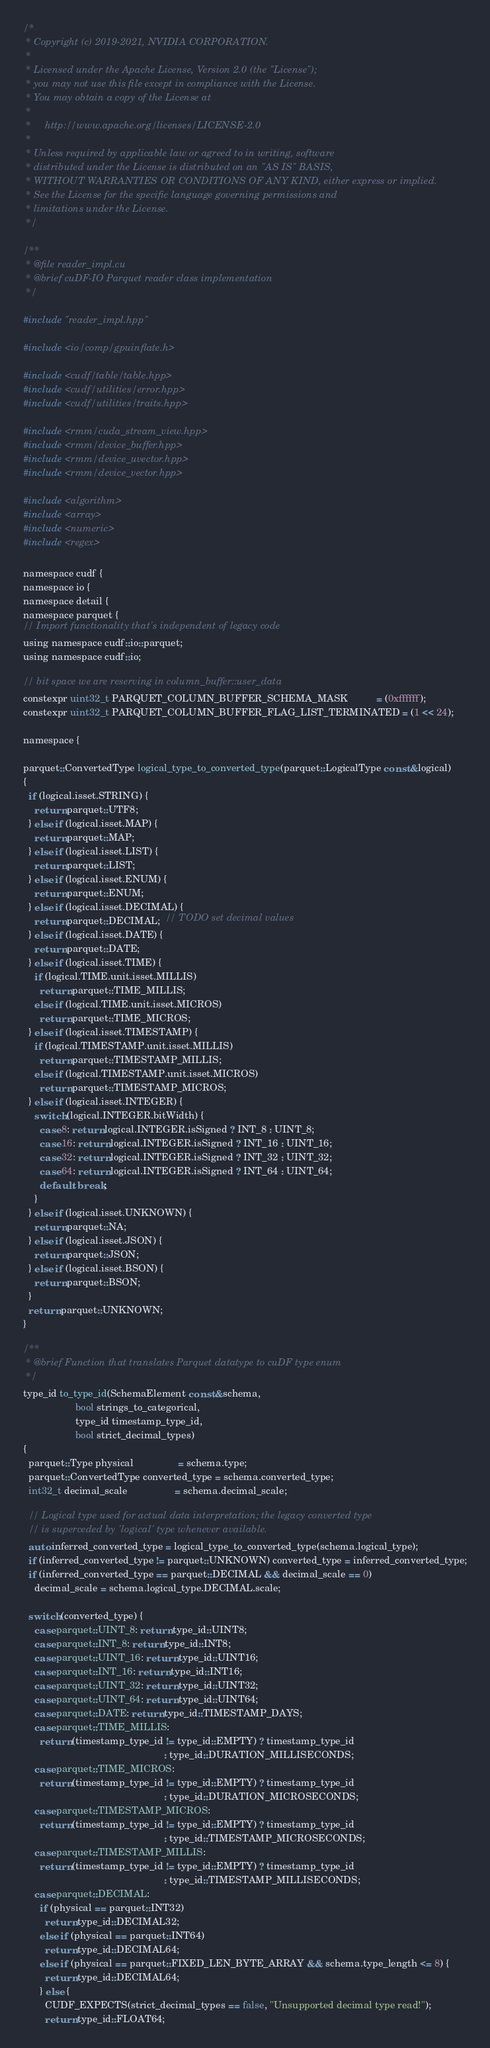<code> <loc_0><loc_0><loc_500><loc_500><_Cuda_>/*
 * Copyright (c) 2019-2021, NVIDIA CORPORATION.
 *
 * Licensed under the Apache License, Version 2.0 (the "License");
 * you may not use this file except in compliance with the License.
 * You may obtain a copy of the License at
 *
 *     http://www.apache.org/licenses/LICENSE-2.0
 *
 * Unless required by applicable law or agreed to in writing, software
 * distributed under the License is distributed on an "AS IS" BASIS,
 * WITHOUT WARRANTIES OR CONDITIONS OF ANY KIND, either express or implied.
 * See the License for the specific language governing permissions and
 * limitations under the License.
 */

/**
 * @file reader_impl.cu
 * @brief cuDF-IO Parquet reader class implementation
 */

#include "reader_impl.hpp"

#include <io/comp/gpuinflate.h>

#include <cudf/table/table.hpp>
#include <cudf/utilities/error.hpp>
#include <cudf/utilities/traits.hpp>

#include <rmm/cuda_stream_view.hpp>
#include <rmm/device_buffer.hpp>
#include <rmm/device_uvector.hpp>
#include <rmm/device_vector.hpp>

#include <algorithm>
#include <array>
#include <numeric>
#include <regex>

namespace cudf {
namespace io {
namespace detail {
namespace parquet {
// Import functionality that's independent of legacy code
using namespace cudf::io::parquet;
using namespace cudf::io;

// bit space we are reserving in column_buffer::user_data
constexpr uint32_t PARQUET_COLUMN_BUFFER_SCHEMA_MASK          = (0xffffff);
constexpr uint32_t PARQUET_COLUMN_BUFFER_FLAG_LIST_TERMINATED = (1 << 24);

namespace {

parquet::ConvertedType logical_type_to_converted_type(parquet::LogicalType const &logical)
{
  if (logical.isset.STRING) {
    return parquet::UTF8;
  } else if (logical.isset.MAP) {
    return parquet::MAP;
  } else if (logical.isset.LIST) {
    return parquet::LIST;
  } else if (logical.isset.ENUM) {
    return parquet::ENUM;
  } else if (logical.isset.DECIMAL) {
    return parquet::DECIMAL;  // TODO set decimal values
  } else if (logical.isset.DATE) {
    return parquet::DATE;
  } else if (logical.isset.TIME) {
    if (logical.TIME.unit.isset.MILLIS)
      return parquet::TIME_MILLIS;
    else if (logical.TIME.unit.isset.MICROS)
      return parquet::TIME_MICROS;
  } else if (logical.isset.TIMESTAMP) {
    if (logical.TIMESTAMP.unit.isset.MILLIS)
      return parquet::TIMESTAMP_MILLIS;
    else if (logical.TIMESTAMP.unit.isset.MICROS)
      return parquet::TIMESTAMP_MICROS;
  } else if (logical.isset.INTEGER) {
    switch (logical.INTEGER.bitWidth) {
      case 8: return logical.INTEGER.isSigned ? INT_8 : UINT_8;
      case 16: return logical.INTEGER.isSigned ? INT_16 : UINT_16;
      case 32: return logical.INTEGER.isSigned ? INT_32 : UINT_32;
      case 64: return logical.INTEGER.isSigned ? INT_64 : UINT_64;
      default: break;
    }
  } else if (logical.isset.UNKNOWN) {
    return parquet::NA;
  } else if (logical.isset.JSON) {
    return parquet::JSON;
  } else if (logical.isset.BSON) {
    return parquet::BSON;
  }
  return parquet::UNKNOWN;
}

/**
 * @brief Function that translates Parquet datatype to cuDF type enum
 */
type_id to_type_id(SchemaElement const &schema,
                   bool strings_to_categorical,
                   type_id timestamp_type_id,
                   bool strict_decimal_types)
{
  parquet::Type physical                = schema.type;
  parquet::ConvertedType converted_type = schema.converted_type;
  int32_t decimal_scale                 = schema.decimal_scale;

  // Logical type used for actual data interpretation; the legacy converted type
  // is superceded by 'logical' type whenever available.
  auto inferred_converted_type = logical_type_to_converted_type(schema.logical_type);
  if (inferred_converted_type != parquet::UNKNOWN) converted_type = inferred_converted_type;
  if (inferred_converted_type == parquet::DECIMAL && decimal_scale == 0)
    decimal_scale = schema.logical_type.DECIMAL.scale;

  switch (converted_type) {
    case parquet::UINT_8: return type_id::UINT8;
    case parquet::INT_8: return type_id::INT8;
    case parquet::UINT_16: return type_id::UINT16;
    case parquet::INT_16: return type_id::INT16;
    case parquet::UINT_32: return type_id::UINT32;
    case parquet::UINT_64: return type_id::UINT64;
    case parquet::DATE: return type_id::TIMESTAMP_DAYS;
    case parquet::TIME_MILLIS:
      return (timestamp_type_id != type_id::EMPTY) ? timestamp_type_id
                                                   : type_id::DURATION_MILLISECONDS;
    case parquet::TIME_MICROS:
      return (timestamp_type_id != type_id::EMPTY) ? timestamp_type_id
                                                   : type_id::DURATION_MICROSECONDS;
    case parquet::TIMESTAMP_MICROS:
      return (timestamp_type_id != type_id::EMPTY) ? timestamp_type_id
                                                   : type_id::TIMESTAMP_MICROSECONDS;
    case parquet::TIMESTAMP_MILLIS:
      return (timestamp_type_id != type_id::EMPTY) ? timestamp_type_id
                                                   : type_id::TIMESTAMP_MILLISECONDS;
    case parquet::DECIMAL:
      if (physical == parquet::INT32)
        return type_id::DECIMAL32;
      else if (physical == parquet::INT64)
        return type_id::DECIMAL64;
      else if (physical == parquet::FIXED_LEN_BYTE_ARRAY && schema.type_length <= 8) {
        return type_id::DECIMAL64;
      } else {
        CUDF_EXPECTS(strict_decimal_types == false, "Unsupported decimal type read!");
        return type_id::FLOAT64;</code> 